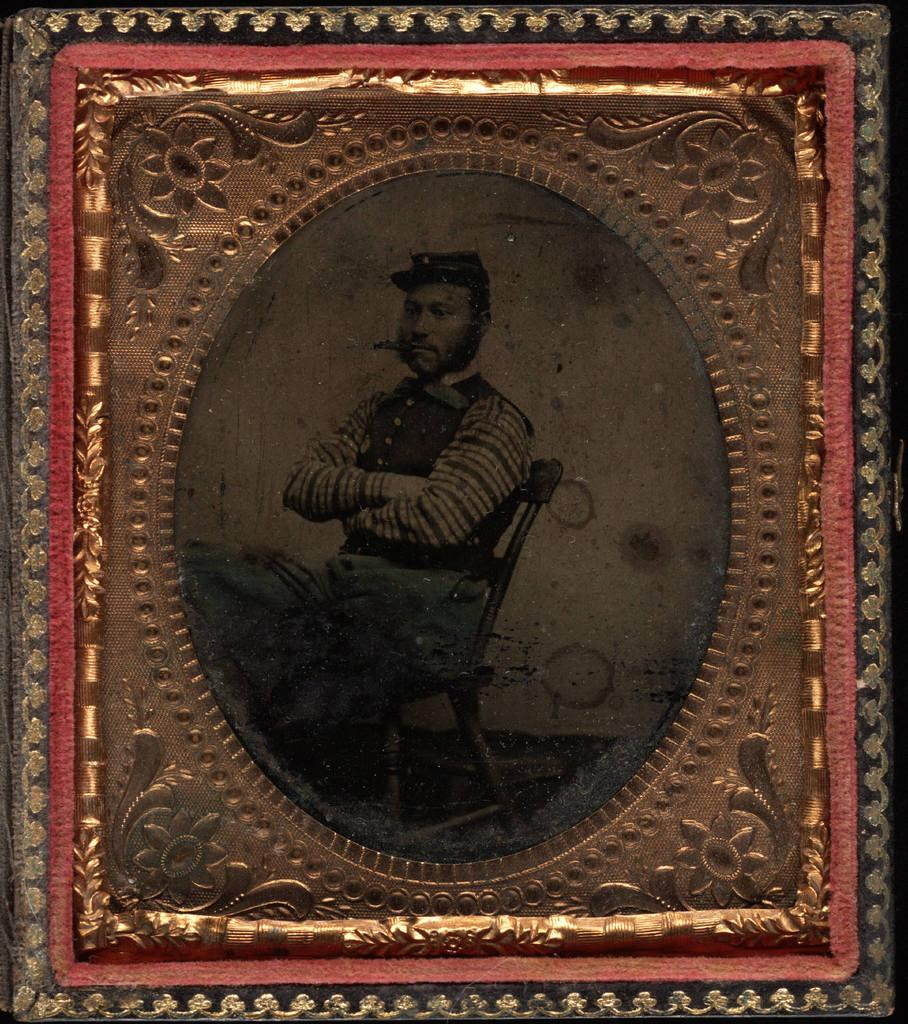What object is present in the image that typically holds a photograph or image? There is a picture frame in the image. What can be seen inside the picture frame? The picture frame contains an image of a person. What is the person in the image doing? The person in the image is sitting on a chair. What is the person holding in his mouth? The person in the picture has a cigar in his mouth. How many tickets can be seen in the image? There are no tickets present in the image. What type of ocean can be seen in the background of the image? There is no ocean present in the image; it features a picture frame with an image of a person sitting on a chair. 